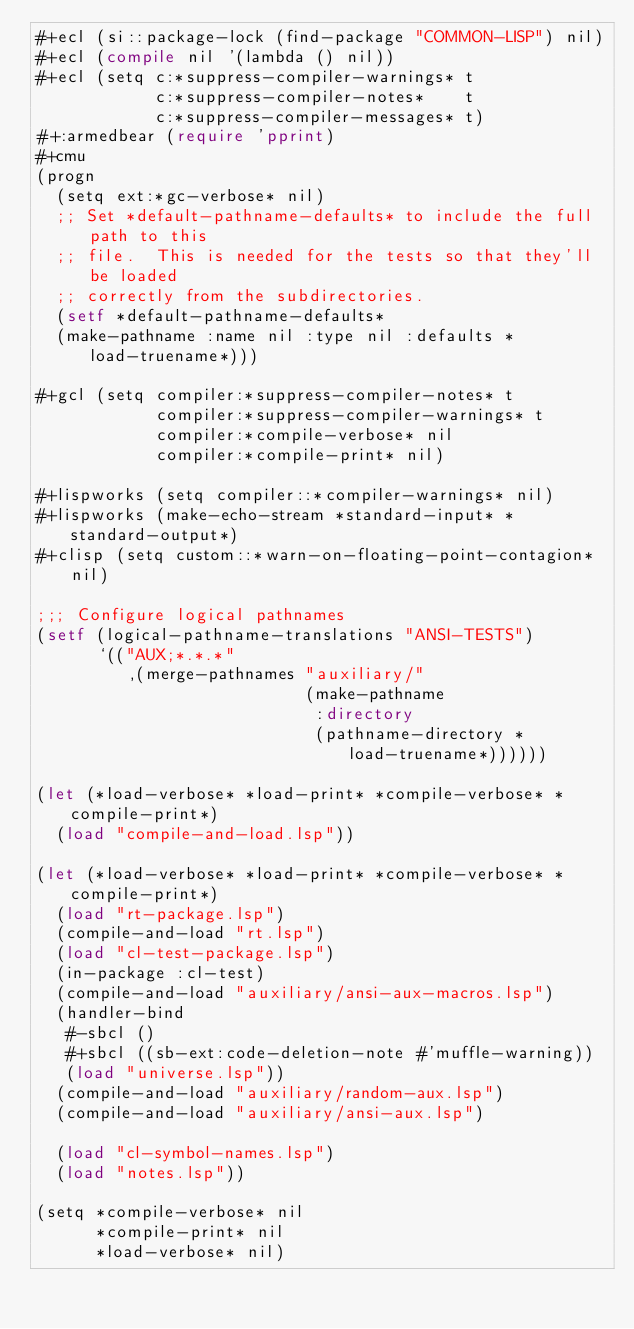<code> <loc_0><loc_0><loc_500><loc_500><_Lisp_>#+ecl (si::package-lock (find-package "COMMON-LISP") nil)
#+ecl (compile nil '(lambda () nil))
#+ecl (setq c:*suppress-compiler-warnings* t
            c:*suppress-compiler-notes*    t
            c:*suppress-compiler-messages* t)
#+:armedbear (require 'pprint)
#+cmu
(progn
  (setq ext:*gc-verbose* nil)
  ;; Set *default-pathname-defaults* to include the full path to this
  ;; file.  This is needed for the tests so that they'll be loaded
  ;; correctly from the subdirectories.
  (setf *default-pathname-defaults*
	(make-pathname :name nil :type nil :defaults *load-truename*)))

#+gcl (setq compiler:*suppress-compiler-notes* t
            compiler:*suppress-compiler-warnings* t
            compiler:*compile-verbose* nil
            compiler:*compile-print* nil)

#+lispworks (setq compiler::*compiler-warnings* nil)
#+lispworks (make-echo-stream *standard-input* *standard-output*)
#+clisp (setq custom::*warn-on-floating-point-contagion* nil)

;;; Configure logical pathnames
(setf (logical-pathname-translations "ANSI-TESTS")
      `(("AUX;*.*.*"
         ,(merge-pathnames "auxiliary/"
                           (make-pathname
                            :directory
                            (pathname-directory *load-truename*))))))

(let (*load-verbose* *load-print* *compile-verbose* *compile-print*)
  (load "compile-and-load.lsp"))

(let (*load-verbose* *load-print* *compile-verbose* *compile-print*)
  (load "rt-package.lsp")
  (compile-and-load "rt.lsp")
  (load "cl-test-package.lsp")
  (in-package :cl-test)
  (compile-and-load "auxiliary/ansi-aux-macros.lsp")
  (handler-bind
   #-sbcl ()
   #+sbcl ((sb-ext:code-deletion-note #'muffle-warning))
   (load "universe.lsp"))
  (compile-and-load "auxiliary/random-aux.lsp")
  (compile-and-load "auxiliary/ansi-aux.lsp")
  
  (load "cl-symbol-names.lsp")
  (load "notes.lsp"))

(setq *compile-verbose* nil
      *compile-print* nil
      *load-verbose* nil)

</code> 